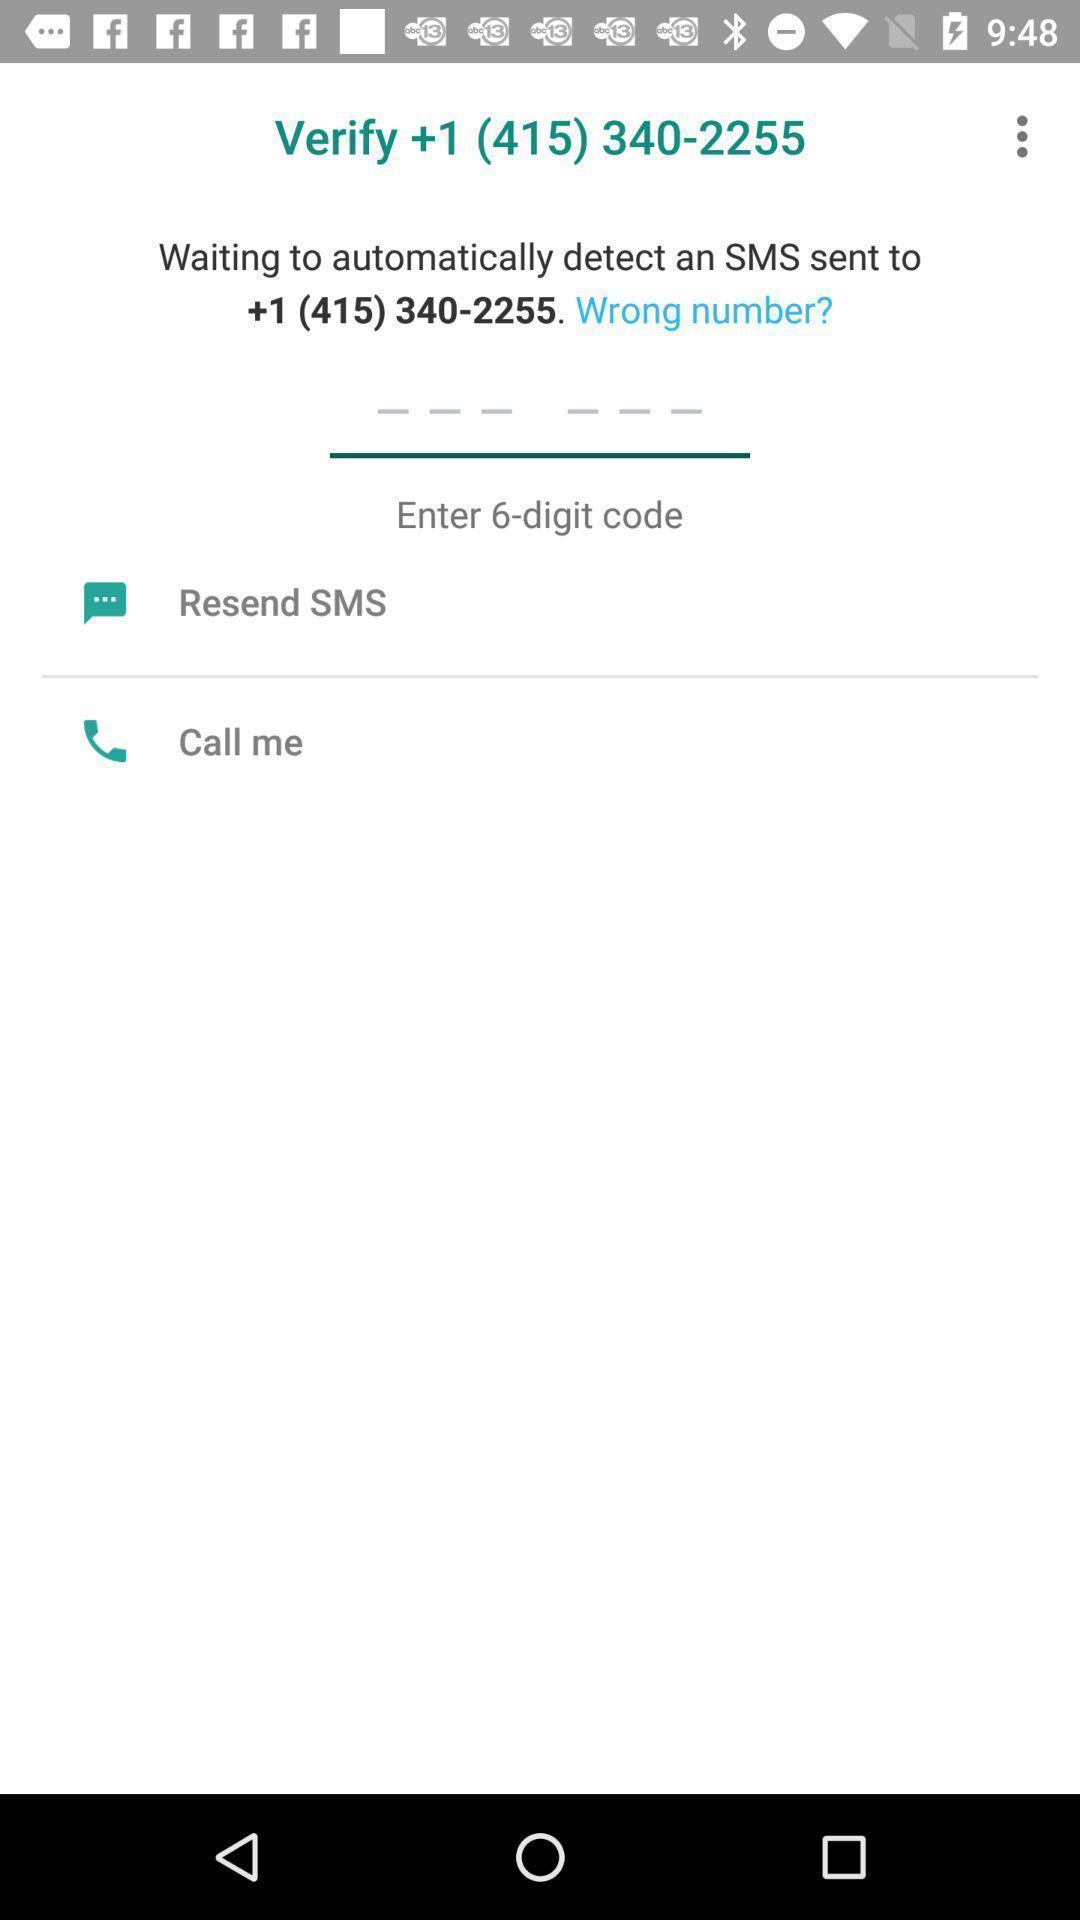What is the overall content of this screenshot? Screen shows to verify number. 